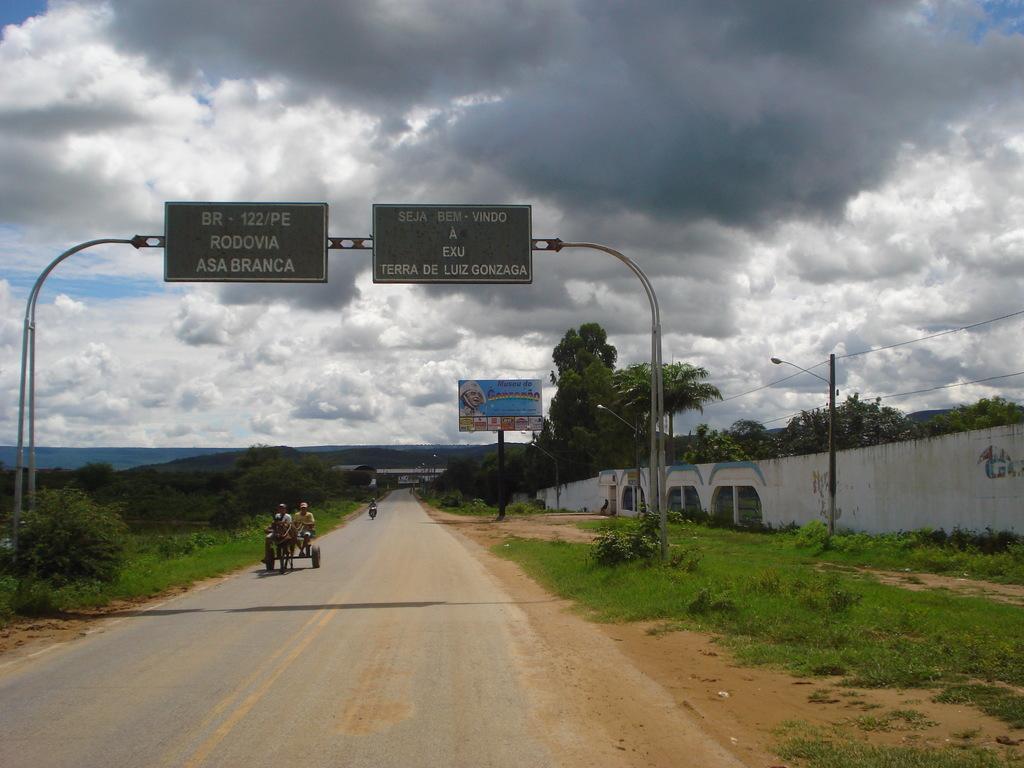Can you describe this image briefly? In the image there is a road in the middle with grassland on either side of it and in the middle there is a donkey cart going on the road, there is an arch above and over the top its sky with clouds. 